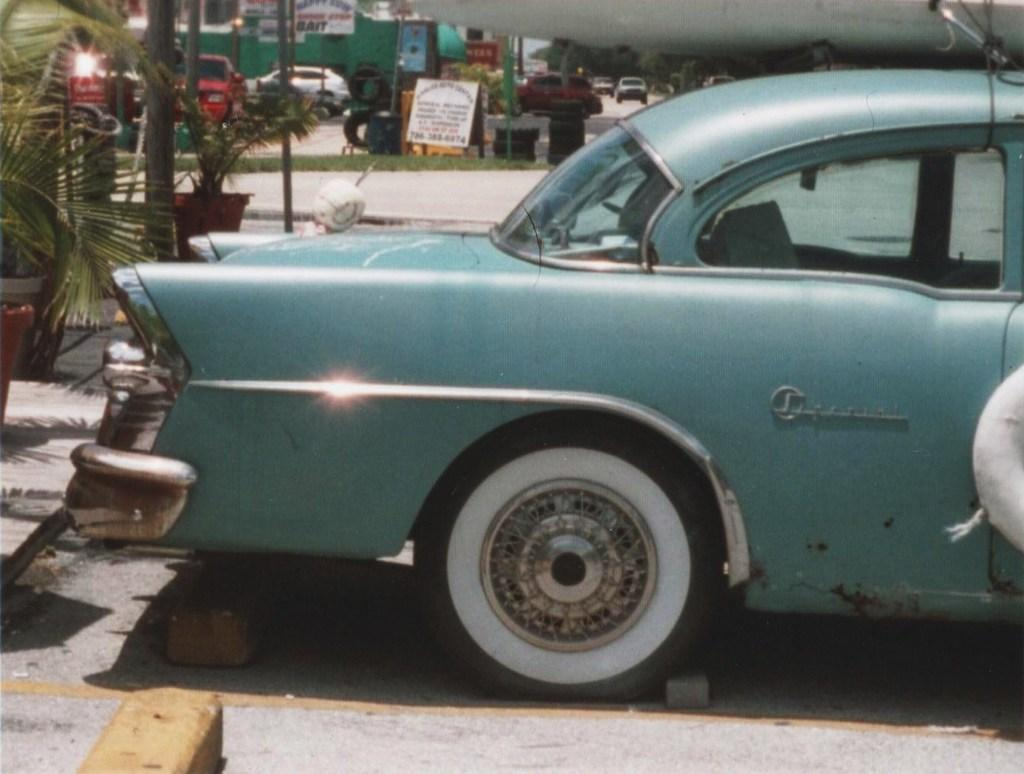What is the main subject in the center of the image? There is a car in the center of the image. Where is the car located? The car is on the road. What can be seen on the left side of the image? There are bricks, plants, trees, a pole, and cars on the left side of the image. What is visible in the background of the image? There are trees, cars, and the sky in the background of the image. How many nails can be seen holding the car to the ground in the image? There are no nails visible in the image, and the car is not being held to the ground by any nails. 